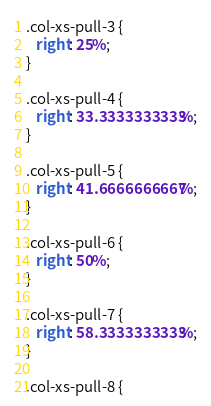<code> <loc_0><loc_0><loc_500><loc_500><_CSS_>
.col-xs-pull-3 {
   right: 25%;
}

.col-xs-pull-4 {
   right: 33.3333333333%;
}

.col-xs-pull-5 {
   right: 41.6666666667%;
}

.col-xs-pull-6 {
   right: 50%;
}

.col-xs-pull-7 {
   right: 58.3333333333%;
}

.col-xs-pull-8 {</code> 